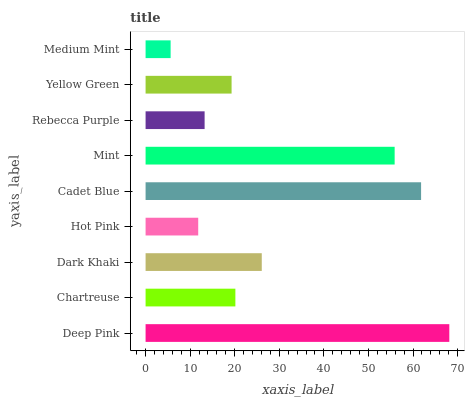Is Medium Mint the minimum?
Answer yes or no. Yes. Is Deep Pink the maximum?
Answer yes or no. Yes. Is Chartreuse the minimum?
Answer yes or no. No. Is Chartreuse the maximum?
Answer yes or no. No. Is Deep Pink greater than Chartreuse?
Answer yes or no. Yes. Is Chartreuse less than Deep Pink?
Answer yes or no. Yes. Is Chartreuse greater than Deep Pink?
Answer yes or no. No. Is Deep Pink less than Chartreuse?
Answer yes or no. No. Is Chartreuse the high median?
Answer yes or no. Yes. Is Chartreuse the low median?
Answer yes or no. Yes. Is Yellow Green the high median?
Answer yes or no. No. Is Dark Khaki the low median?
Answer yes or no. No. 